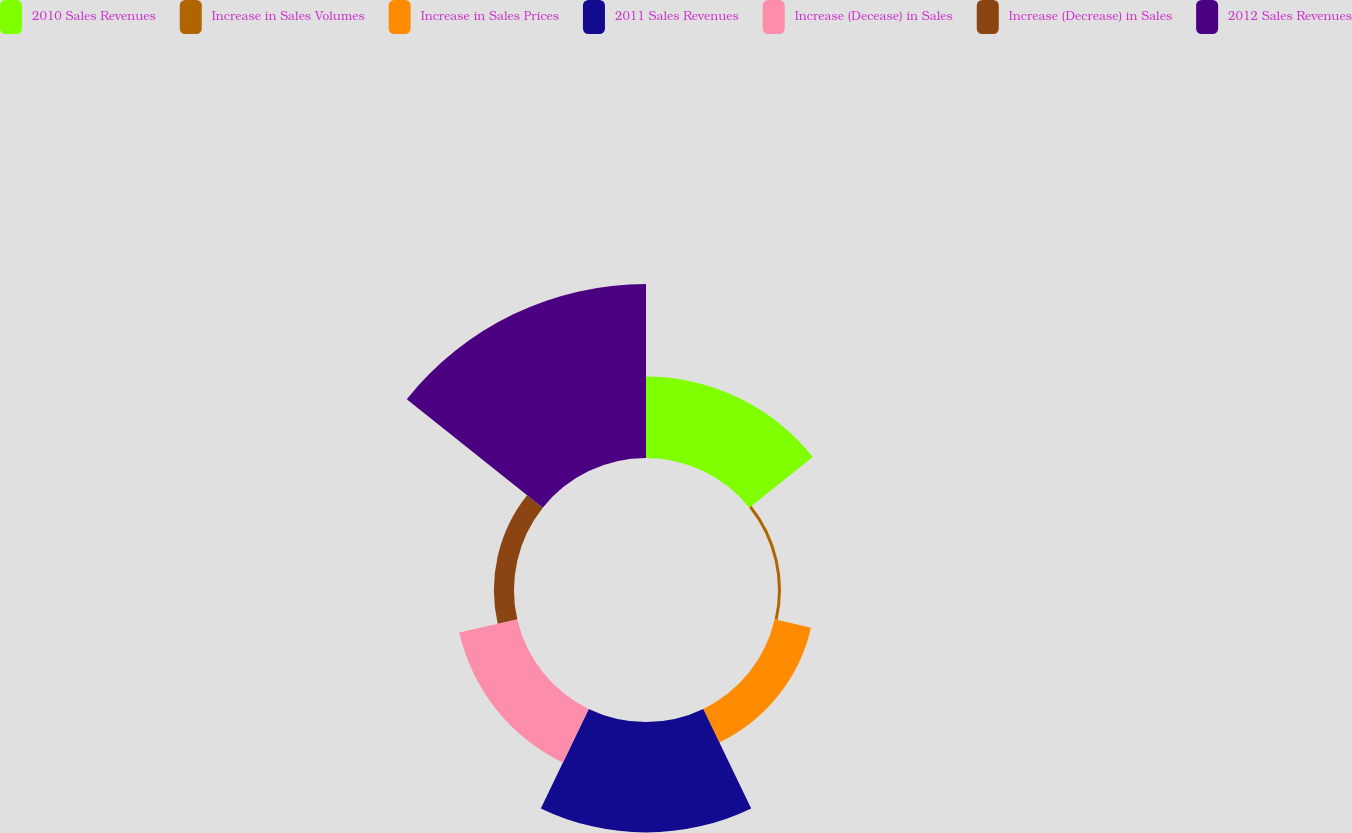Convert chart. <chart><loc_0><loc_0><loc_500><loc_500><pie_chart><fcel>2010 Sales Revenues<fcel>Increase in Sales Volumes<fcel>Increase in Sales Prices<fcel>2011 Sales Revenues<fcel>Increase (Decease) in Sales<fcel>Increase (Decrease) in Sales<fcel>2012 Sales Revenues<nl><fcel>16.76%<fcel>0.61%<fcel>7.66%<fcel>22.74%<fcel>12.26%<fcel>4.14%<fcel>35.83%<nl></chart> 